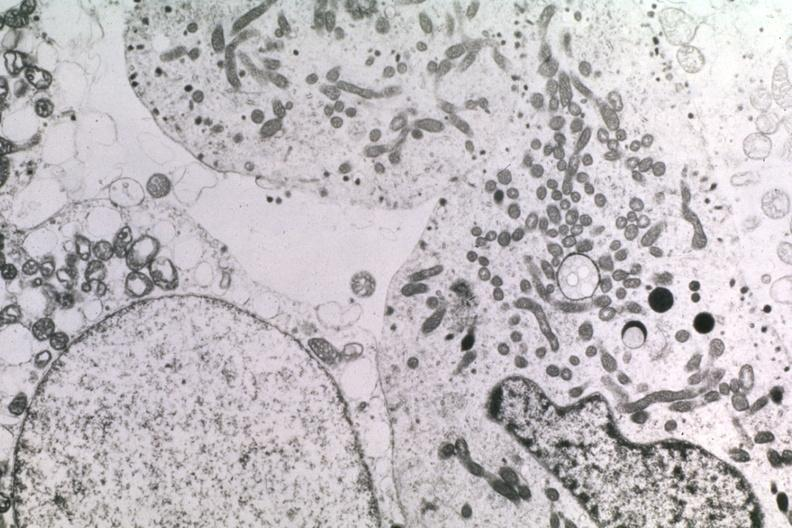s adenoma present?
Answer the question using a single word or phrase. Yes 